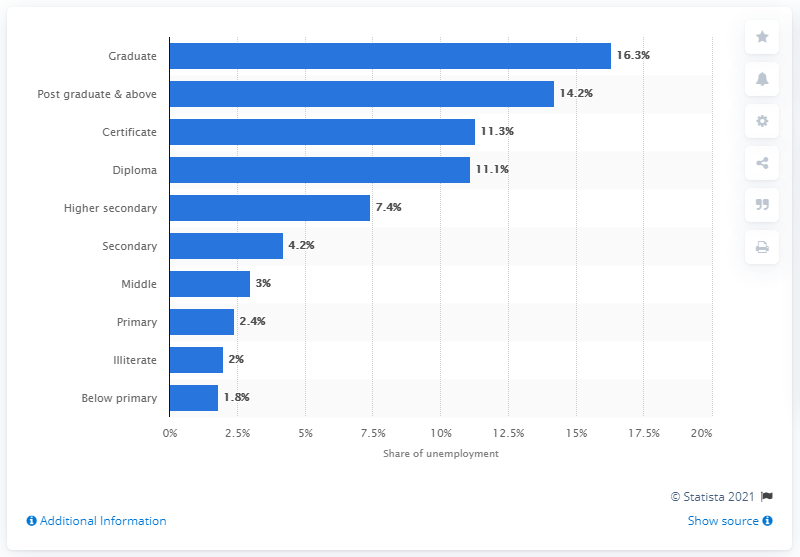Which educational qualification had the second-highest unemployment rate in 2019? The second-highest unemployment rate in 2019 was among individuals with postgraduate and above qualifications, registering at 14.2%. 